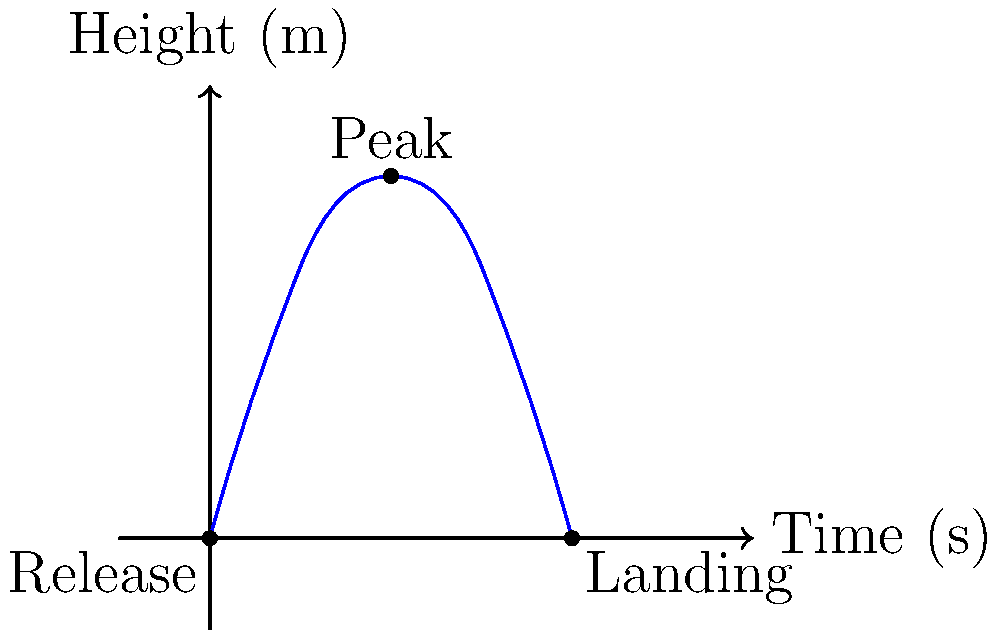Analyze the trajectory of a wheelchair athlete throwing a discus as shown in the graph. If the discus is released at ground level and reaches a maximum height of 4 meters after 2 seconds, what is the initial vertical velocity $v_0$ of the discus in m/s? Assume negligible air resistance and use $g = 9.8 \text{ m/s}^2$ for acceleration due to gravity. Let's approach this step-by-step:

1) We can use the equation for the height of an object under constant acceleration:

   $y = y_0 + v_0t - \frac{1}{2}gt^2$

   Where:
   $y$ is the height
   $y_0$ is the initial height (0 in this case)
   $v_0$ is the initial vertical velocity (what we're solving for)
   $t$ is the time
   $g$ is the acceleration due to gravity (9.8 m/s²)

2) At the peak of the trajectory, the height is 4 m and the time is 2 s. Let's plug these into our equation:

   $4 = 0 + v_0(2) - \frac{1}{2}(9.8)(2^2)$

3) Simplify:
   $4 = 2v_0 - 19.6$

4) Add 19.6 to both sides:
   $23.6 = 2v_0$

5) Divide both sides by 2:
   $11.8 = v_0$

Therefore, the initial vertical velocity is 11.8 m/s.
Answer: 11.8 m/s 